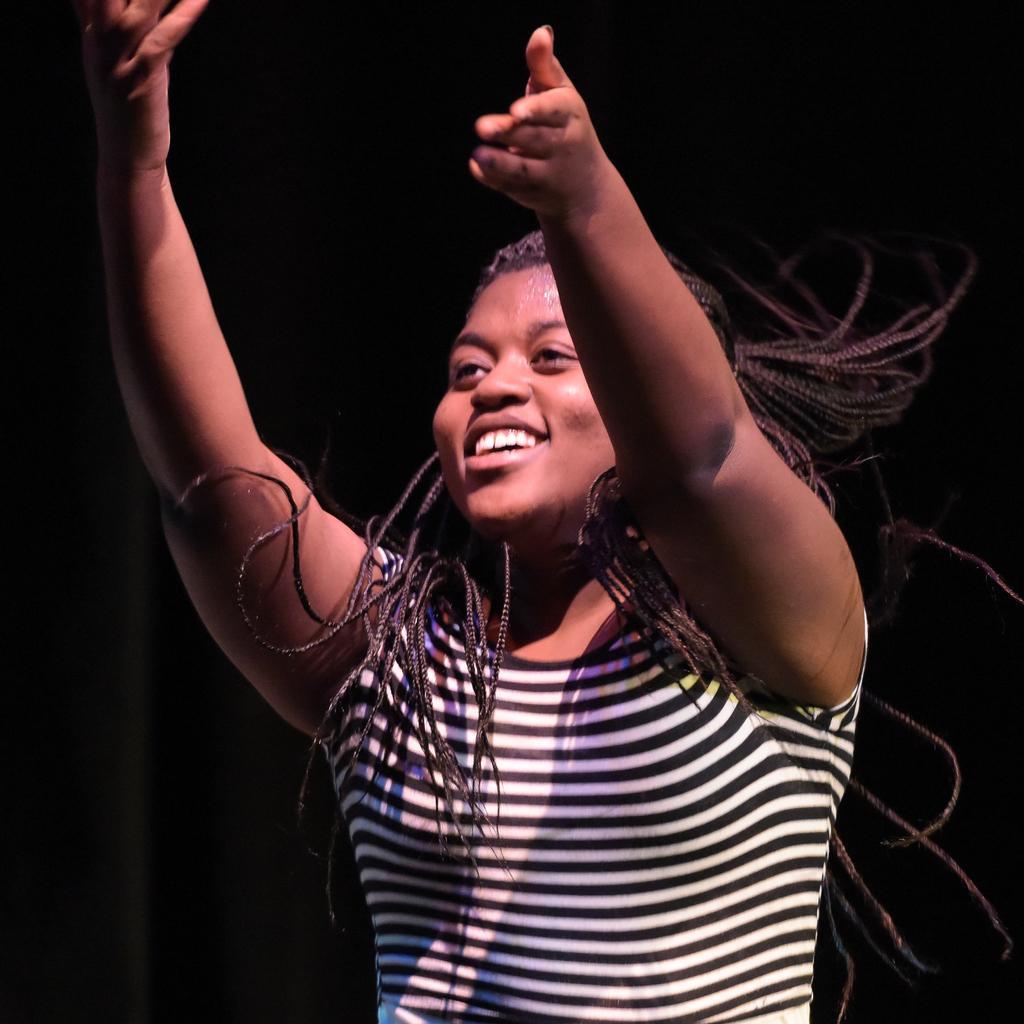Describe this image in one or two sentences. In this image in the center there is a woman standing and smiling. 